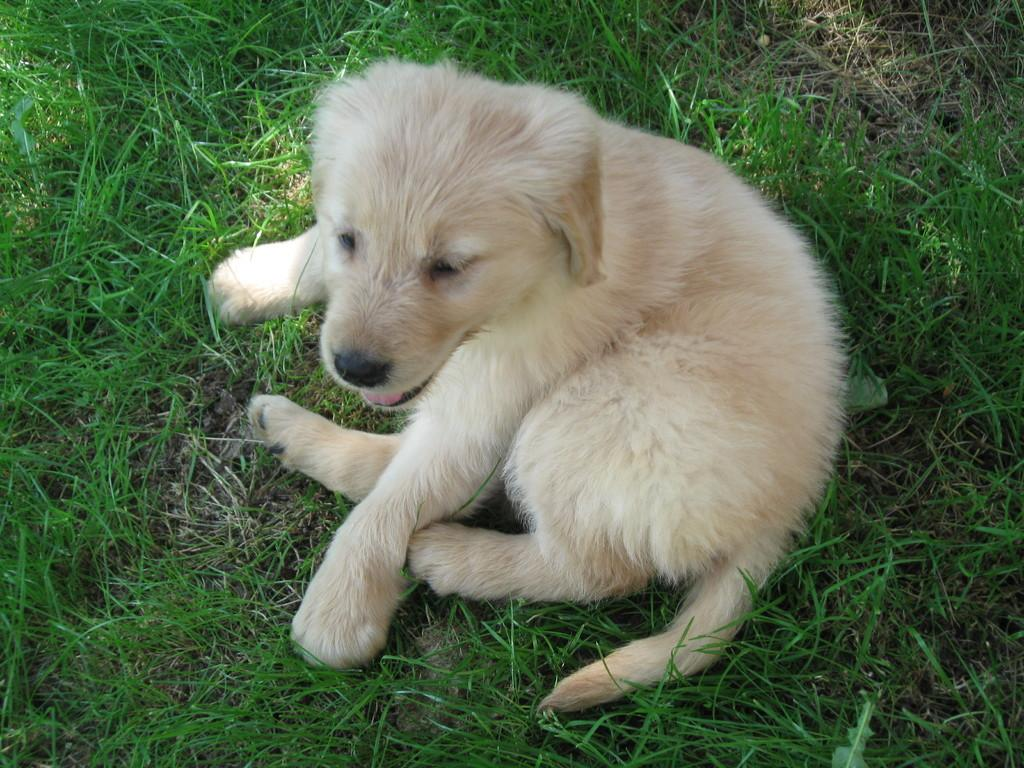What is the main subject of the image? There is a puppy in the image. What is the puppy laying on? The puppy is laying on grass. What is the puppy's mind made of in the image? The image does not provide information about the puppy's mind, as it is a visual representation and does not delve into the thoughts or mental processes of the puppy. What type of yarn is the puppy holding in the image? There is no yarn present in the image; the puppy is simply laying on grass. 